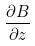<formula> <loc_0><loc_0><loc_500><loc_500>\frac { \partial B } { \partial z }</formula> 